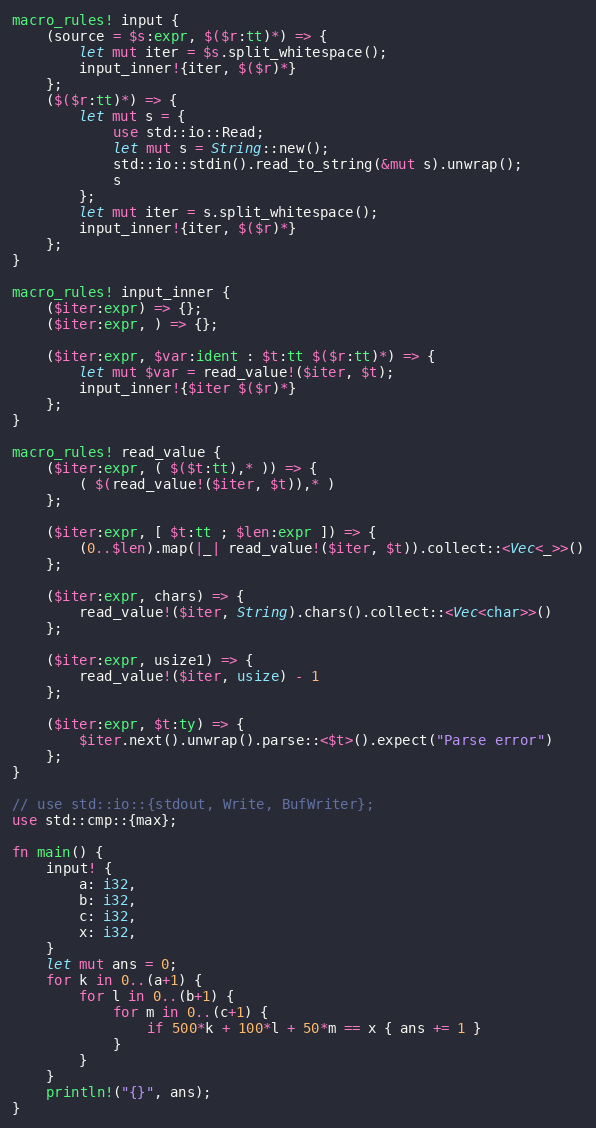Convert code to text. <code><loc_0><loc_0><loc_500><loc_500><_Rust_>macro_rules! input {
    (source = $s:expr, $($r:tt)*) => {
        let mut iter = $s.split_whitespace();
        input_inner!{iter, $($r)*}
    };
    ($($r:tt)*) => {
        let mut s = {
            use std::io::Read;
            let mut s = String::new();
            std::io::stdin().read_to_string(&mut s).unwrap();
            s
        };
        let mut iter = s.split_whitespace();
        input_inner!{iter, $($r)*}
    };
}

macro_rules! input_inner {
    ($iter:expr) => {};
    ($iter:expr, ) => {};

    ($iter:expr, $var:ident : $t:tt $($r:tt)*) => {
        let mut $var = read_value!($iter, $t);
        input_inner!{$iter $($r)*}
    };
}

macro_rules! read_value {
    ($iter:expr, ( $($t:tt),* )) => {
        ( $(read_value!($iter, $t)),* )
    };

    ($iter:expr, [ $t:tt ; $len:expr ]) => {
        (0..$len).map(|_| read_value!($iter, $t)).collect::<Vec<_>>()
    };

    ($iter:expr, chars) => {
        read_value!($iter, String).chars().collect::<Vec<char>>()
    };

    ($iter:expr, usize1) => {
        read_value!($iter, usize) - 1
    };

    ($iter:expr, $t:ty) => {
        $iter.next().unwrap().parse::<$t>().expect("Parse error")
    };
}

// use std::io::{stdout, Write, BufWriter};
use std::cmp::{max};

fn main() {
    input! {
        a: i32,
        b: i32,
        c: i32,
        x: i32,
    }
    let mut ans = 0;
    for k in 0..(a+1) {
        for l in 0..(b+1) {
            for m in 0..(c+1) {
                if 500*k + 100*l + 50*m == x { ans += 1 }
            }
        }
    }
    println!("{}", ans);
}
</code> 